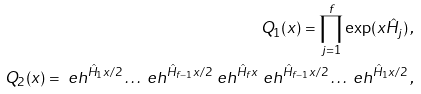Convert formula to latex. <formula><loc_0><loc_0><loc_500><loc_500>Q _ { 1 } ( x ) = \prod _ { j = 1 } ^ { f } \exp ( x \hat { H } _ { j } ) \, , \\ Q _ { 2 } ( x ) = \ e h ^ { \hat { H } _ { 1 } x / 2 } \dots \ e h ^ { \hat { H } _ { f - 1 } x / 2 } \ e h ^ { \hat { H } _ { f } x } \ e h ^ { \hat { H } _ { f - 1 } x / 2 } \dots \ e h ^ { \hat { H } _ { 1 } x / 2 } \, ,</formula> 